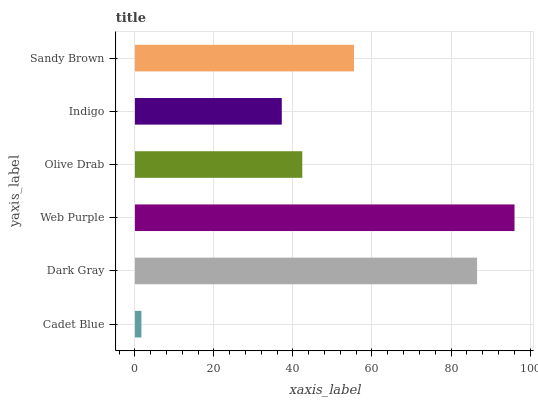Is Cadet Blue the minimum?
Answer yes or no. Yes. Is Web Purple the maximum?
Answer yes or no. Yes. Is Dark Gray the minimum?
Answer yes or no. No. Is Dark Gray the maximum?
Answer yes or no. No. Is Dark Gray greater than Cadet Blue?
Answer yes or no. Yes. Is Cadet Blue less than Dark Gray?
Answer yes or no. Yes. Is Cadet Blue greater than Dark Gray?
Answer yes or no. No. Is Dark Gray less than Cadet Blue?
Answer yes or no. No. Is Sandy Brown the high median?
Answer yes or no. Yes. Is Olive Drab the low median?
Answer yes or no. Yes. Is Dark Gray the high median?
Answer yes or no. No. Is Indigo the low median?
Answer yes or no. No. 